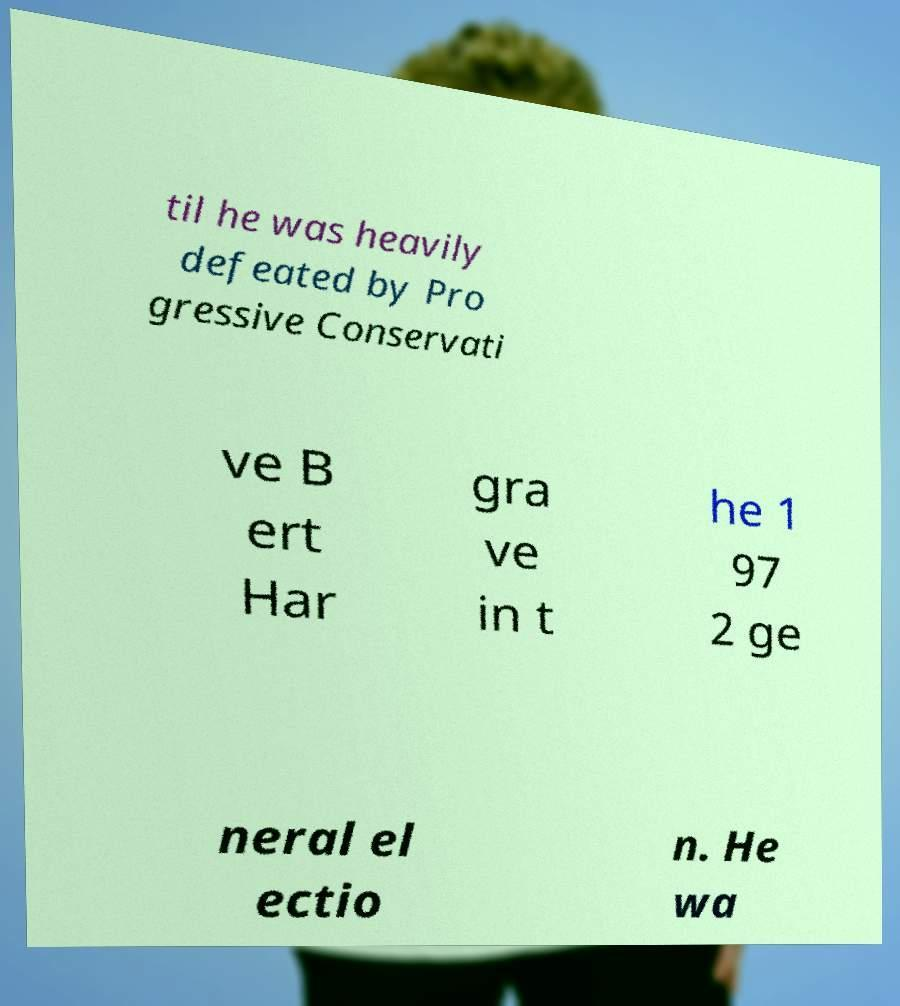Please identify and transcribe the text found in this image. til he was heavily defeated by Pro gressive Conservati ve B ert Har gra ve in t he 1 97 2 ge neral el ectio n. He wa 